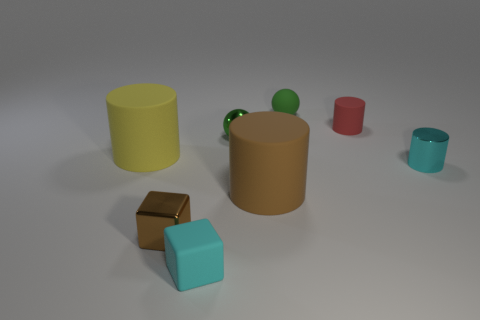Subtract all matte cylinders. How many cylinders are left? 1 Subtract 1 balls. How many balls are left? 1 Subtract all spheres. How many objects are left? 6 Add 2 small blue metal cylinders. How many objects exist? 10 Subtract all red cylinders. How many cylinders are left? 3 Subtract all cyan cylinders. How many brown blocks are left? 1 Subtract all brown matte cylinders. Subtract all large brown rubber things. How many objects are left? 6 Add 1 small matte spheres. How many small matte spheres are left? 2 Add 2 small yellow things. How many small yellow things exist? 2 Subtract 0 purple spheres. How many objects are left? 8 